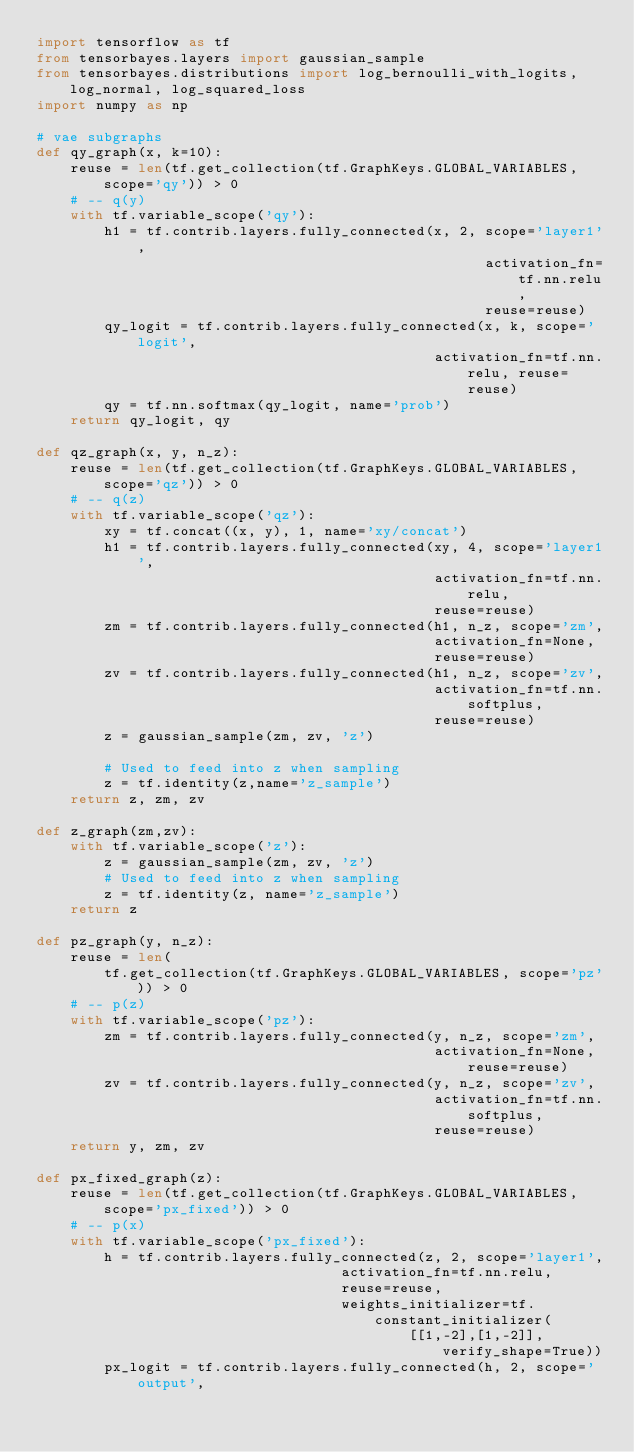Convert code to text. <code><loc_0><loc_0><loc_500><loc_500><_Python_>import tensorflow as tf
from tensorbayes.layers import gaussian_sample
from tensorbayes.distributions import log_bernoulli_with_logits, log_normal, log_squared_loss
import numpy as np

# vae subgraphs
def qy_graph(x, k=10):
    reuse = len(tf.get_collection(tf.GraphKeys.GLOBAL_VARIABLES, scope='qy')) > 0
    # -- q(y)
    with tf.variable_scope('qy'):
        h1 = tf.contrib.layers.fully_connected(x, 2, scope='layer1',
                                                     activation_fn=tf.nn.relu,
                                                     reuse=reuse)
        qy_logit = tf.contrib.layers.fully_connected(x, k, scope='logit',
                                               activation_fn=tf.nn.relu, reuse=reuse)
        qy = tf.nn.softmax(qy_logit, name='prob')
    return qy_logit, qy

def qz_graph(x, y, n_z):
    reuse = len(tf.get_collection(tf.GraphKeys.GLOBAL_VARIABLES, scope='qz')) > 0
    # -- q(z)
    with tf.variable_scope('qz'):
        xy = tf.concat((x, y), 1, name='xy/concat')
        h1 = tf.contrib.layers.fully_connected(xy, 4, scope='layer1',
                                               activation_fn=tf.nn.relu,
                                               reuse=reuse)
        zm = tf.contrib.layers.fully_connected(h1, n_z, scope='zm',
                                               activation_fn=None,
                                               reuse=reuse)
        zv = tf.contrib.layers.fully_connected(h1, n_z, scope='zv',
                                               activation_fn=tf.nn.softplus,
                                               reuse=reuse)
        z = gaussian_sample(zm, zv, 'z')

        # Used to feed into z when sampling
        z = tf.identity(z,name='z_sample')
    return z, zm, zv

def z_graph(zm,zv):
    with tf.variable_scope('z'):
        z = gaussian_sample(zm, zv, 'z')
        # Used to feed into z when sampling
        z = tf.identity(z, name='z_sample')
    return z

def pz_graph(y, n_z):
    reuse = len(
        tf.get_collection(tf.GraphKeys.GLOBAL_VARIABLES, scope='pz')) > 0
    # -- p(z)
    with tf.variable_scope('pz'):
        zm = tf.contrib.layers.fully_connected(y, n_z, scope='zm',
                                               activation_fn=None, reuse=reuse)
        zv = tf.contrib.layers.fully_connected(y, n_z, scope='zv',
                                               activation_fn=tf.nn.softplus,
                                               reuse=reuse)
    return y, zm, zv

def px_fixed_graph(z):
    reuse = len(tf.get_collection(tf.GraphKeys.GLOBAL_VARIABLES, scope='px_fixed')) > 0
    # -- p(x)
    with tf.variable_scope('px_fixed'):
        h = tf.contrib.layers.fully_connected(z, 2, scope='layer1',
                                    activation_fn=tf.nn.relu,
                                    reuse=reuse,
                                    weights_initializer=tf.constant_initializer(
                                            [[1,-2],[1,-2]], verify_shape=True))
        px_logit = tf.contrib.layers.fully_connected(h, 2, scope='output',</code> 